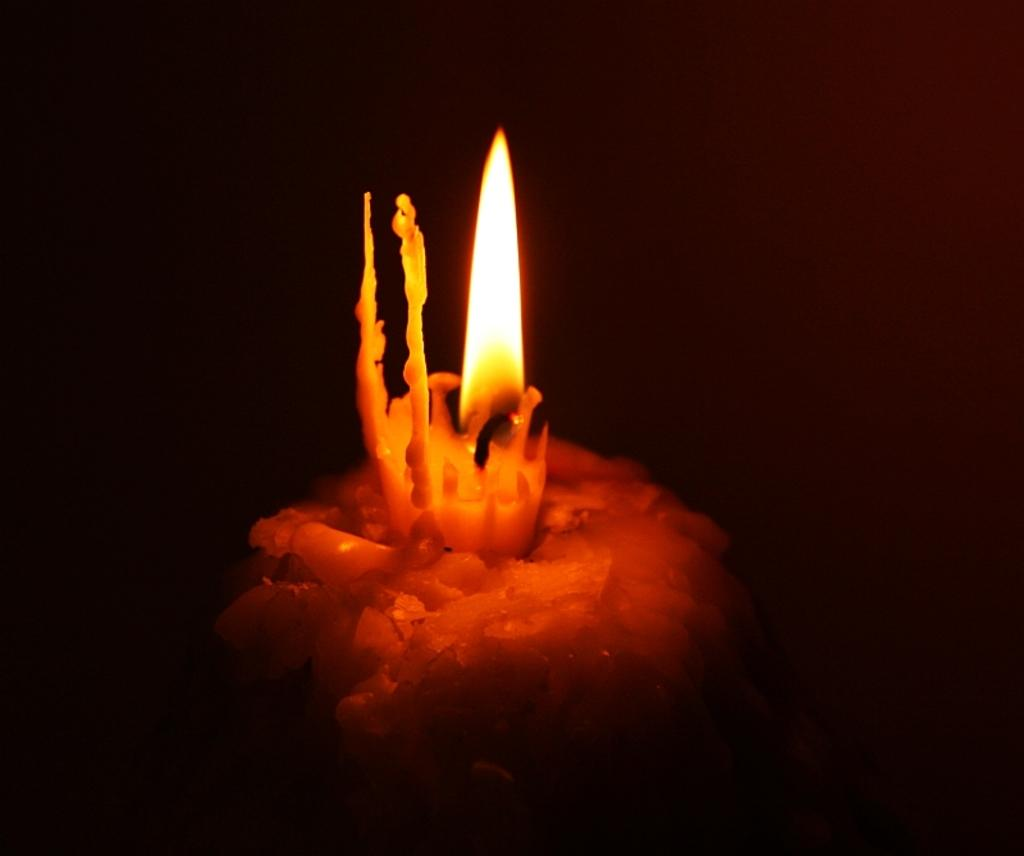What type of candle is in the image? There is a lightning candle in the image. What else can be seen in the image besides the candle? There is a cake in the image. Where is the candle placed on the cake? The candle is placed on the cake. What type of jelly is used to decorate the cake in the image? There is no jelly present on the cake in the image. What branch is holding the lightning candle in the image? There is no branch holding the lightning candle in the image; it is placed directly on the cake. 